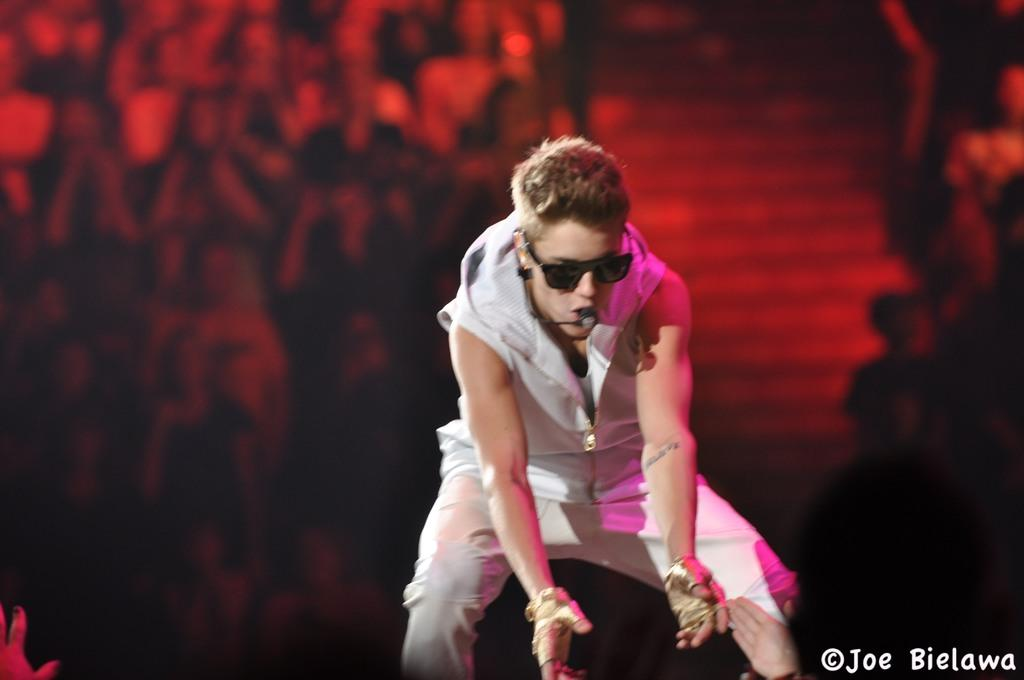How many people are in the image? There is a group of people in the image. Where are the people in relation to another person? The group of people is behind a person. What architectural feature can be seen in the image? There are staircases in the image. What is one person doing in the image? A person is speaking into a microphone. What type of sidewalk can be seen in the image? There is no sidewalk present in the image. What is the size of the person speaking into the microphone? The size of the person speaking into the microphone cannot be determined from the image. 